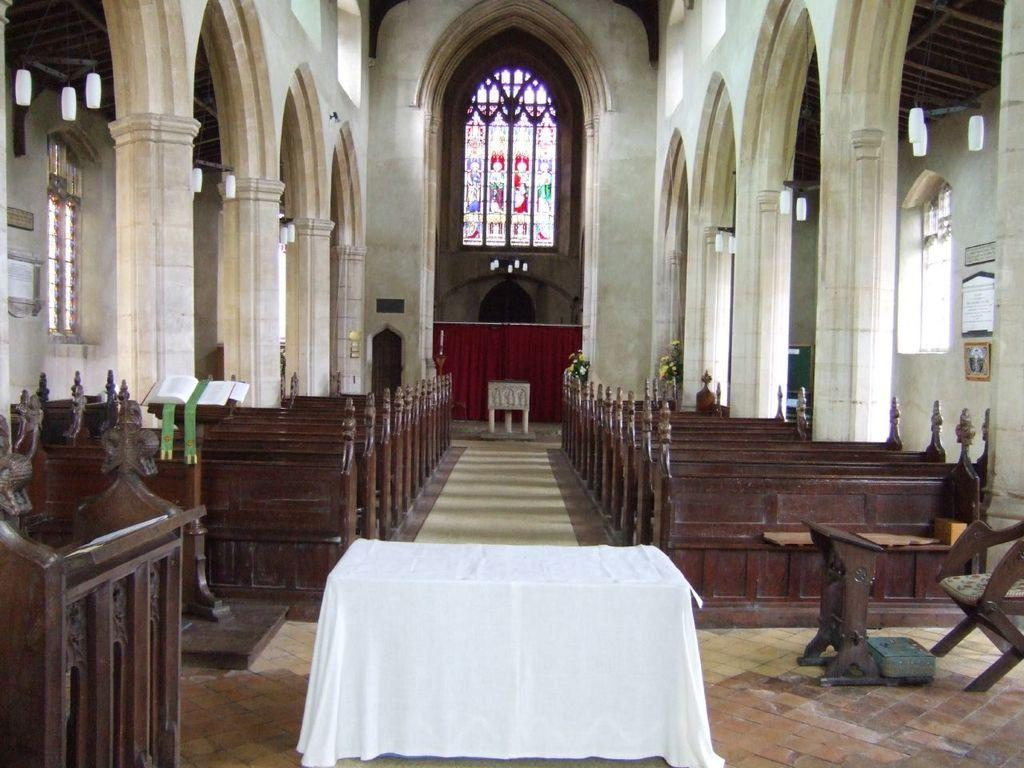What type of furniture can be seen in the image? There are tables, chairs, and benches in the image. What is the primary structure in the image? There is a podium in the image. What is used to hold books in the image? There is a book stand in the image. What architectural elements are present in the image? There are pillars in the image. What is used for displaying information in the image? There are boards in the image. What is used for covering or dividing spaces in the image? There is a curtain in the image. What provides natural light in the image? There are windows in the image. What type of material is present in the image? There is cloth in the image. What type of vegetation is present in the image? There are plants in the image. What unspecified objects can be seen in the image? There are unspecified objects in the image. What type of polish is being applied to the wire in the image? There is no wire or polish present in the image. How many deer can be seen in the image? There are no deer present in the image. 